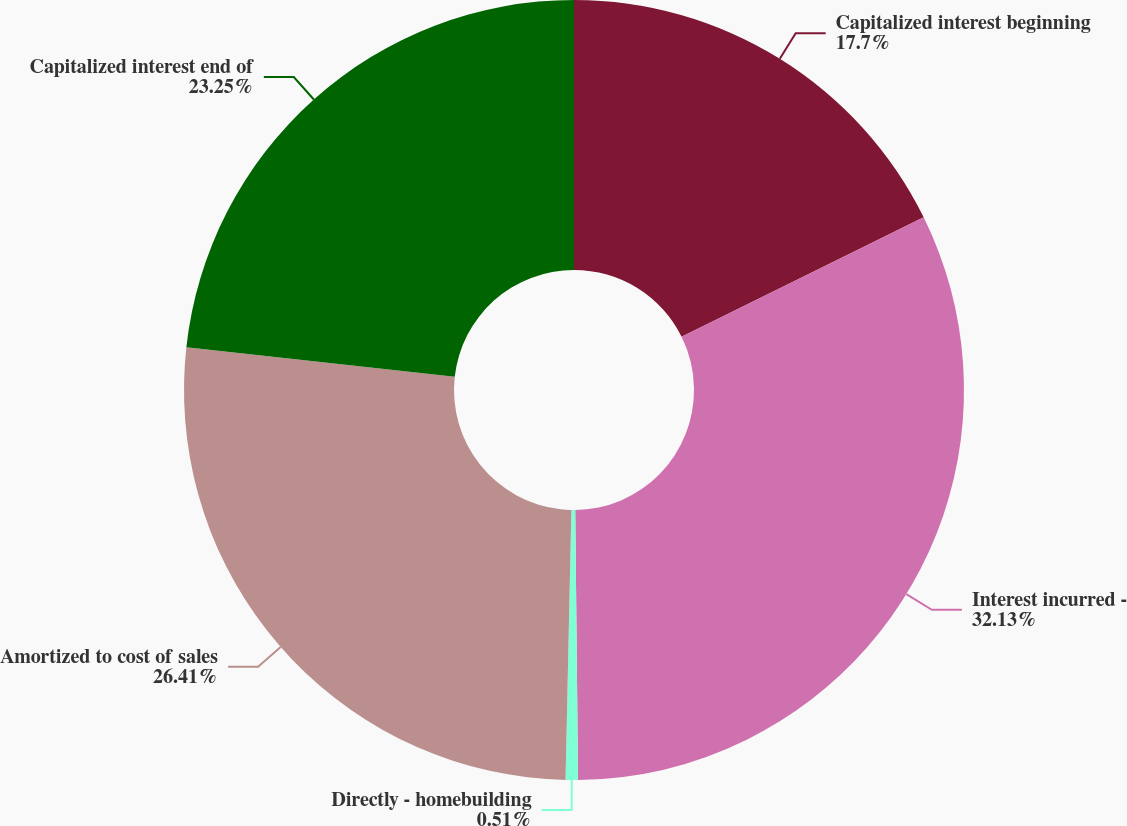Convert chart to OTSL. <chart><loc_0><loc_0><loc_500><loc_500><pie_chart><fcel>Capitalized interest beginning<fcel>Interest incurred -<fcel>Directly - homebuilding<fcel>Amortized to cost of sales<fcel>Capitalized interest end of<nl><fcel>17.7%<fcel>32.14%<fcel>0.51%<fcel>26.41%<fcel>23.25%<nl></chart> 